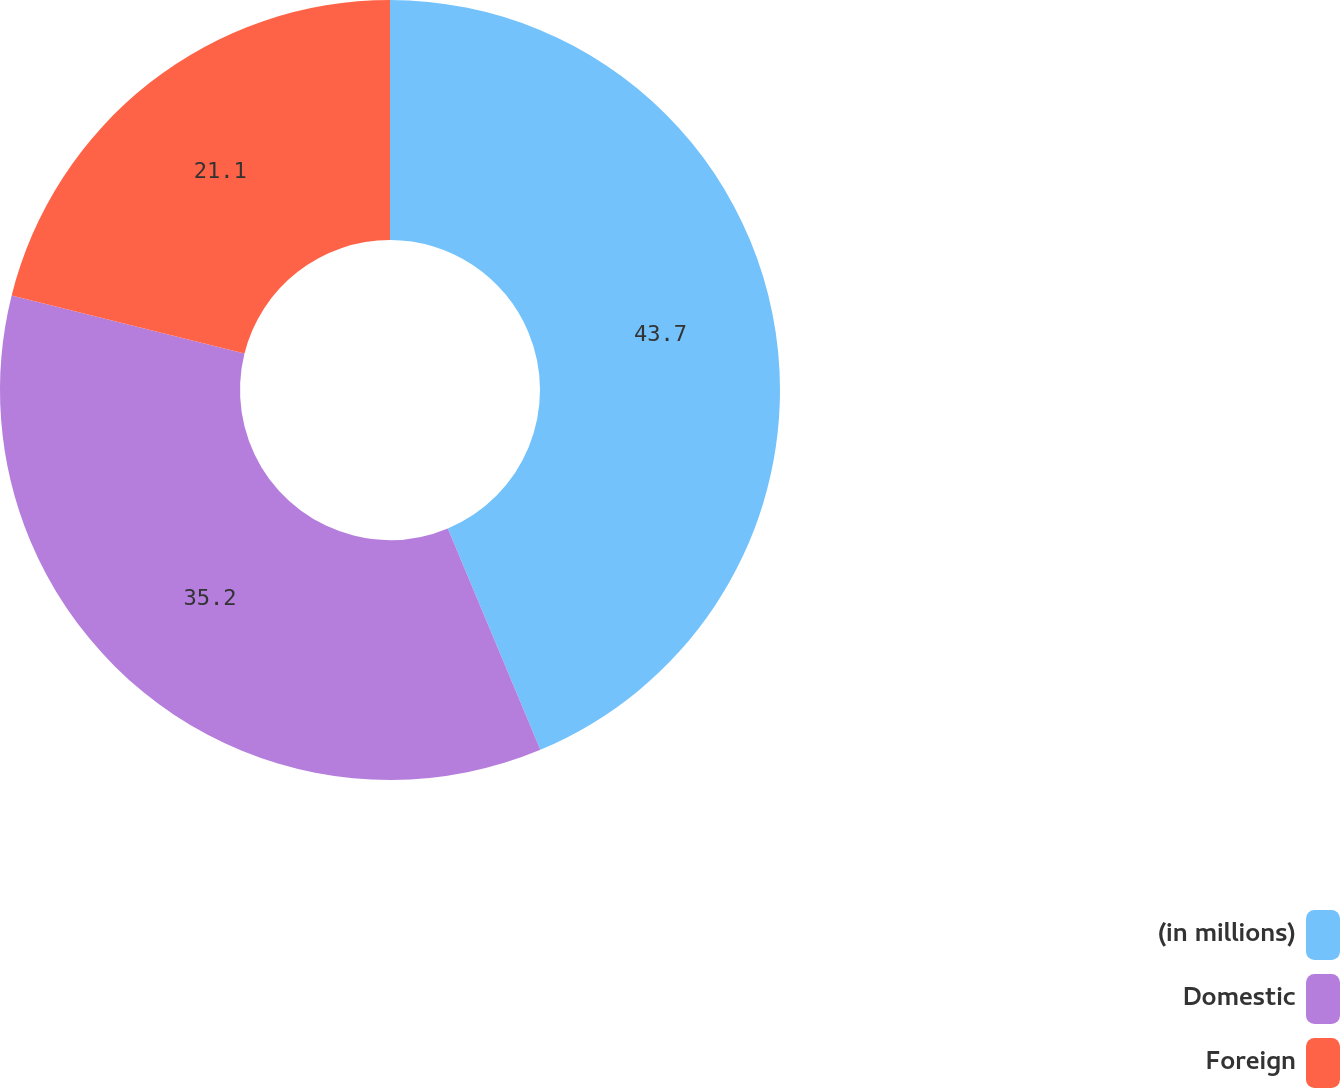Convert chart. <chart><loc_0><loc_0><loc_500><loc_500><pie_chart><fcel>(in millions)<fcel>Domestic<fcel>Foreign<nl><fcel>43.7%<fcel>35.2%<fcel>21.1%<nl></chart> 